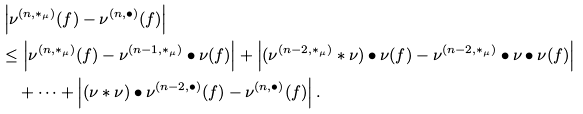Convert formula to latex. <formula><loc_0><loc_0><loc_500><loc_500>& \left | \nu ^ { ( n , * _ { \mu } ) } ( f ) - \nu ^ { ( n , \bullet ) } ( f ) \right | \\ & \leq \left | \nu ^ { ( n , * _ { \mu } ) } ( f ) - \nu ^ { ( n - 1 , * _ { \mu } ) } \bullet \nu ( f ) \right | + \left | ( \nu ^ { ( n - 2 , * _ { \mu } ) } * \nu ) \bullet \nu ( f ) - \nu ^ { ( n - 2 , * _ { \mu } ) } \bullet \nu \bullet \nu ( f ) \right | \\ & \quad + \dots + \left | ( \nu * \nu ) \bullet \nu ^ { ( n - 2 , \bullet ) } ( f ) - \nu ^ { ( n , \bullet ) } ( f ) \right | .</formula> 